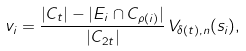Convert formula to latex. <formula><loc_0><loc_0><loc_500><loc_500>v _ { i } = \frac { | C _ { t } | - | E _ { i } \cap C _ { \rho ( i ) } | } { | C _ { 2 t } | } \, V _ { \delta ( t ) , n } ( s _ { i } ) ,</formula> 